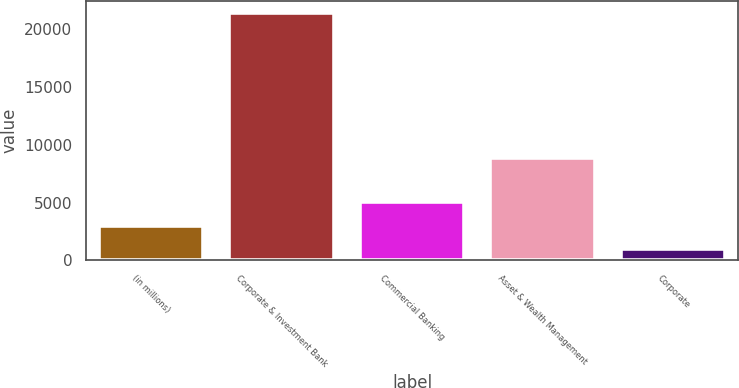Convert chart to OTSL. <chart><loc_0><loc_0><loc_500><loc_500><bar_chart><fcel>(in millions)<fcel>Corporate & Investment Bank<fcel>Commercial Banking<fcel>Asset & Wealth Management<fcel>Corporate<nl><fcel>3015.4<fcel>21361<fcel>5053.8<fcel>8886<fcel>977<nl></chart> 